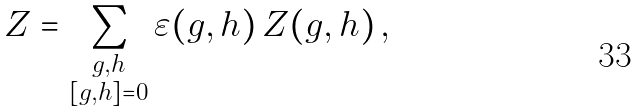Convert formula to latex. <formula><loc_0><loc_0><loc_500><loc_500>Z = \sum _ { \substack { g , h \\ [ g , h ] = 0 } } \varepsilon ( g , h ) \, Z ( g , h ) \, ,</formula> 